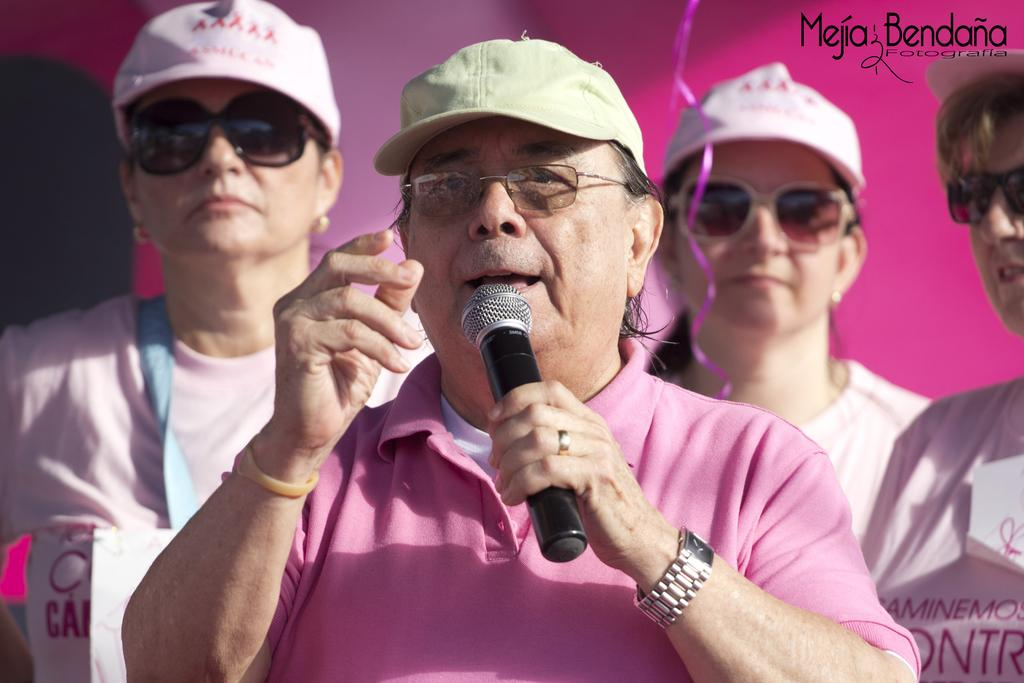How many people are in the image? There is a group of people in the image. What are the people wearing on their heads? The people are wearing hats in the image. What else are the people wearing? The people are also wearing glasses in the image. What is the person in the front holding? The person in the front is holding a microphone. What type of news can be heard coming from the sink in the image? There is no sink present in the image, and therefore no news can be heard coming from it. 